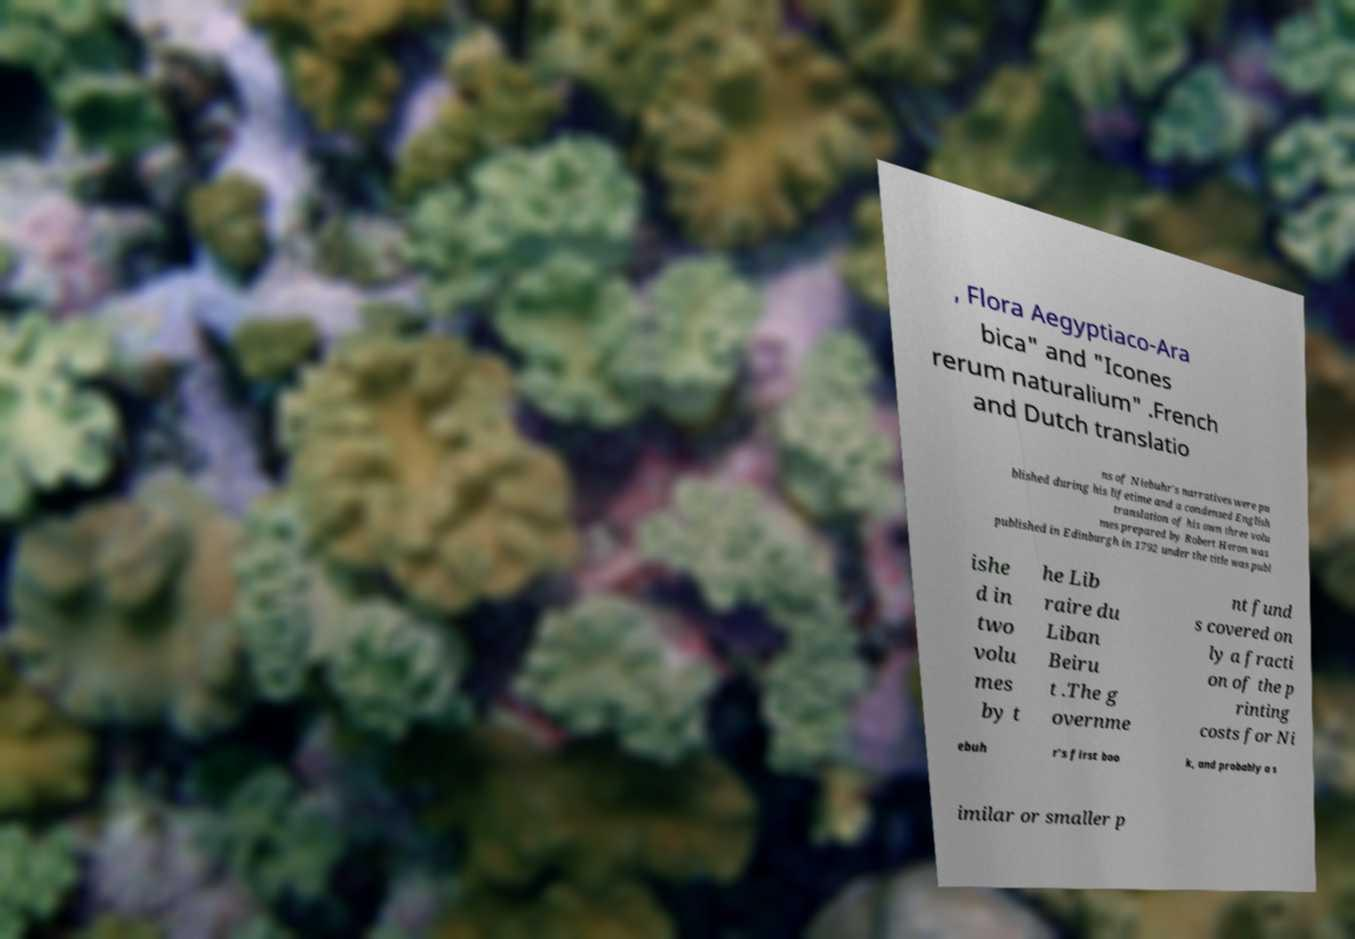Please read and relay the text visible in this image. What does it say? , Flora Aegyptiaco-Ara bica" and "Icones rerum naturalium" .French and Dutch translatio ns of Niebuhr's narratives were pu blished during his lifetime and a condensed English translation of his own three volu mes prepared by Robert Heron was published in Edinburgh in 1792 under the title was publ ishe d in two volu mes by t he Lib raire du Liban Beiru t .The g overnme nt fund s covered on ly a fracti on of the p rinting costs for Ni ebuh r's first boo k, and probably a s imilar or smaller p 